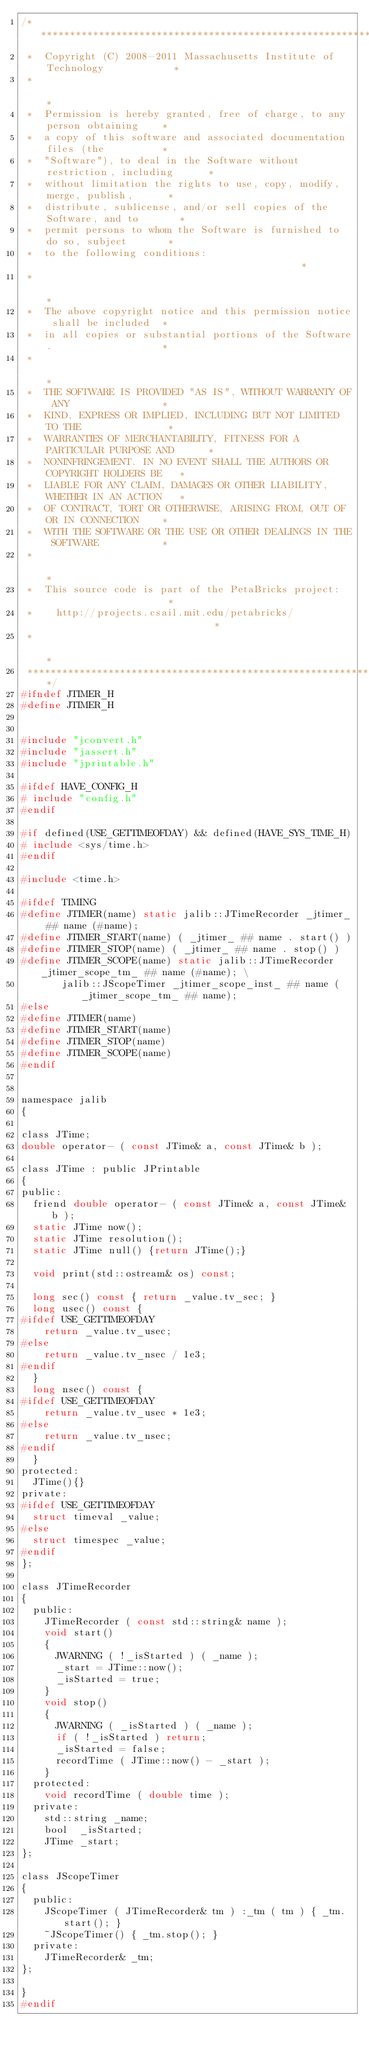Convert code to text. <code><loc_0><loc_0><loc_500><loc_500><_C_>/*****************************************************************************
 *  Copyright (C) 2008-2011 Massachusetts Institute of Technology            *
 *                                                                           *
 *  Permission is hereby granted, free of charge, to any person obtaining    *
 *  a copy of this software and associated documentation files (the          *
 *  "Software"), to deal in the Software without restriction, including      *
 *  without limitation the rights to use, copy, modify, merge, publish,      *
 *  distribute, sublicense, and/or sell copies of the Software, and to       *
 *  permit persons to whom the Software is furnished to do so, subject       *
 *  to the following conditions:                                             *
 *                                                                           *
 *  The above copyright notice and this permission notice shall be included  *
 *  in all copies or substantial portions of the Software.                   *
 *                                                                           *
 *  THE SOFTWARE IS PROVIDED "AS IS", WITHOUT WARRANTY OF ANY                *
 *  KIND, EXPRESS OR IMPLIED, INCLUDING BUT NOT LIMITED TO THE               *
 *  WARRANTIES OF MERCHANTABILITY, FITNESS FOR A PARTICULAR PURPOSE AND      *
 *  NONINFRINGEMENT. IN NO EVENT SHALL THE AUTHORS OR COPYRIGHT HOLDERS BE   *
 *  LIABLE FOR ANY CLAIM, DAMAGES OR OTHER LIABILITY, WHETHER IN AN ACTION   *
 *  OF CONTRACT, TORT OR OTHERWISE, ARISING FROM, OUT OF OR IN CONNECTION    *
 *  WITH THE SOFTWARE OR THE USE OR OTHER DEALINGS IN THE SOFTWARE           *
 *                                                                           *
 *  This source code is part of the PetaBricks project:                      *
 *    http://projects.csail.mit.edu/petabricks/                              *
 *                                                                           *
 *****************************************************************************/
#ifndef JTIMER_H
#define JTIMER_H


#include "jconvert.h"
#include "jassert.h"
#include "jprintable.h"

#ifdef HAVE_CONFIG_H
# include "config.h"
#endif

#if defined(USE_GETTIMEOFDAY) && defined(HAVE_SYS_TIME_H)
# include <sys/time.h>
#endif

#include <time.h>

#ifdef TIMING
#define JTIMER(name) static jalib::JTimeRecorder _jtimer_ ## name (#name);
#define JTIMER_START(name) ( _jtimer_ ## name . start() )
#define JTIMER_STOP(name) ( _jtimer_ ## name . stop() )
#define JTIMER_SCOPE(name) static jalib::JTimeRecorder _jtimer_scope_tm_ ## name (#name); \
       jalib::JScopeTimer _jtimer_scope_inst_ ## name (_jtimer_scope_tm_ ## name);
#else
#define JTIMER(name)
#define JTIMER_START(name)
#define JTIMER_STOP(name)
#define JTIMER_SCOPE(name)
#endif


namespace jalib
{

class JTime;
double operator- ( const JTime& a, const JTime& b );

class JTime : public JPrintable
{
public:
  friend double operator- ( const JTime& a, const JTime& b );
  static JTime now();
  static JTime resolution();
  static JTime null() {return JTime();}

  void print(std::ostream& os) const;
  
  long sec() const { return _value.tv_sec; }
  long usec() const {
#ifdef USE_GETTIMEOFDAY
    return _value.tv_usec;
#else
    return _value.tv_nsec / 1e3;
#endif
  }
  long nsec() const {
#ifdef USE_GETTIMEOFDAY
    return _value.tv_usec * 1e3;
#else
    return _value.tv_nsec;
#endif
  }
protected:
  JTime(){}
private:
#ifdef USE_GETTIMEOFDAY
  struct timeval _value;
#else
  struct timespec _value;
#endif
};

class JTimeRecorder
{
  public:
    JTimeRecorder ( const std::string& name );
    void start()
    {
      JWARNING ( !_isStarted ) ( _name );
      _start = JTime::now();
      _isStarted = true;
    }
    void stop()
    {
      JWARNING ( _isStarted ) ( _name );
      if ( !_isStarted ) return;
      _isStarted = false;
      recordTime ( JTime::now() - _start );
    }
  protected:
    void recordTime ( double time );
  private:
    std::string _name;
    bool  _isStarted;
    JTime _start;
};

class JScopeTimer
{
  public:
    JScopeTimer ( JTimeRecorder& tm ) :_tm ( tm ) { _tm.start(); }
    ~JScopeTimer() { _tm.stop(); }
  private:
    JTimeRecorder& _tm;
};

}
#endif
</code> 